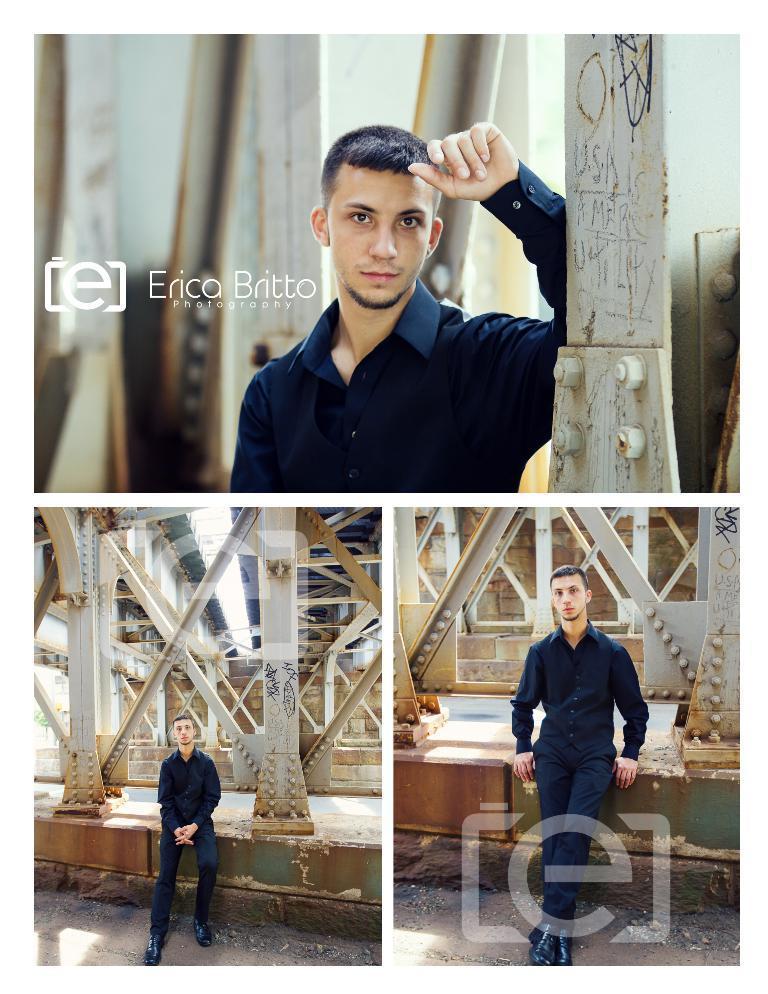Can you describe this image briefly? In this image I can see a person wearing black dress and few poles. I can see a collage image. 